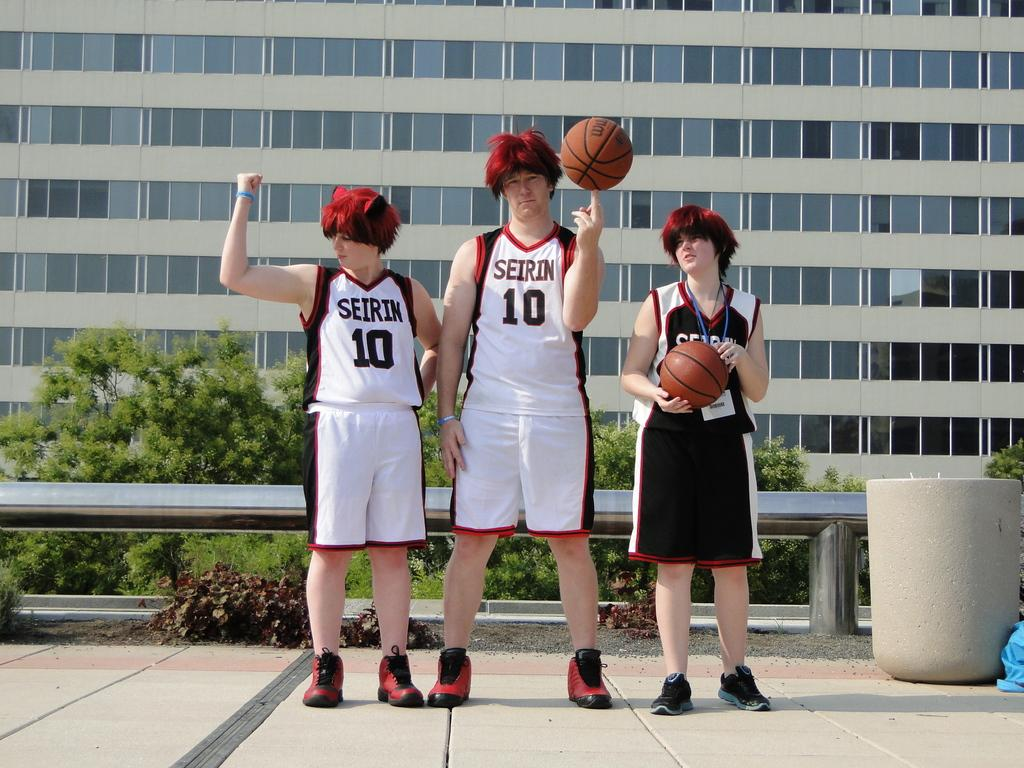<image>
Render a clear and concise summary of the photo. Three people in red wigs and basketball clothes for the Seirin team in front of a building 